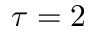<formula> <loc_0><loc_0><loc_500><loc_500>\tau = 2</formula> 